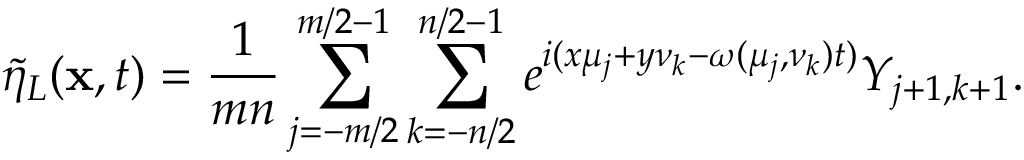<formula> <loc_0><loc_0><loc_500><loc_500>\tilde { \eta } _ { L } ( x , t ) = \frac { 1 } { m n } \sum _ { j = - m / 2 } ^ { m / 2 - 1 } \sum _ { k = - n / 2 } ^ { n / 2 - 1 } e ^ { i ( x \mu _ { j } + y \nu _ { k } - \omega ( \mu _ { j } , \nu _ { k } ) t ) } Y _ { j + 1 , k + 1 } .</formula> 